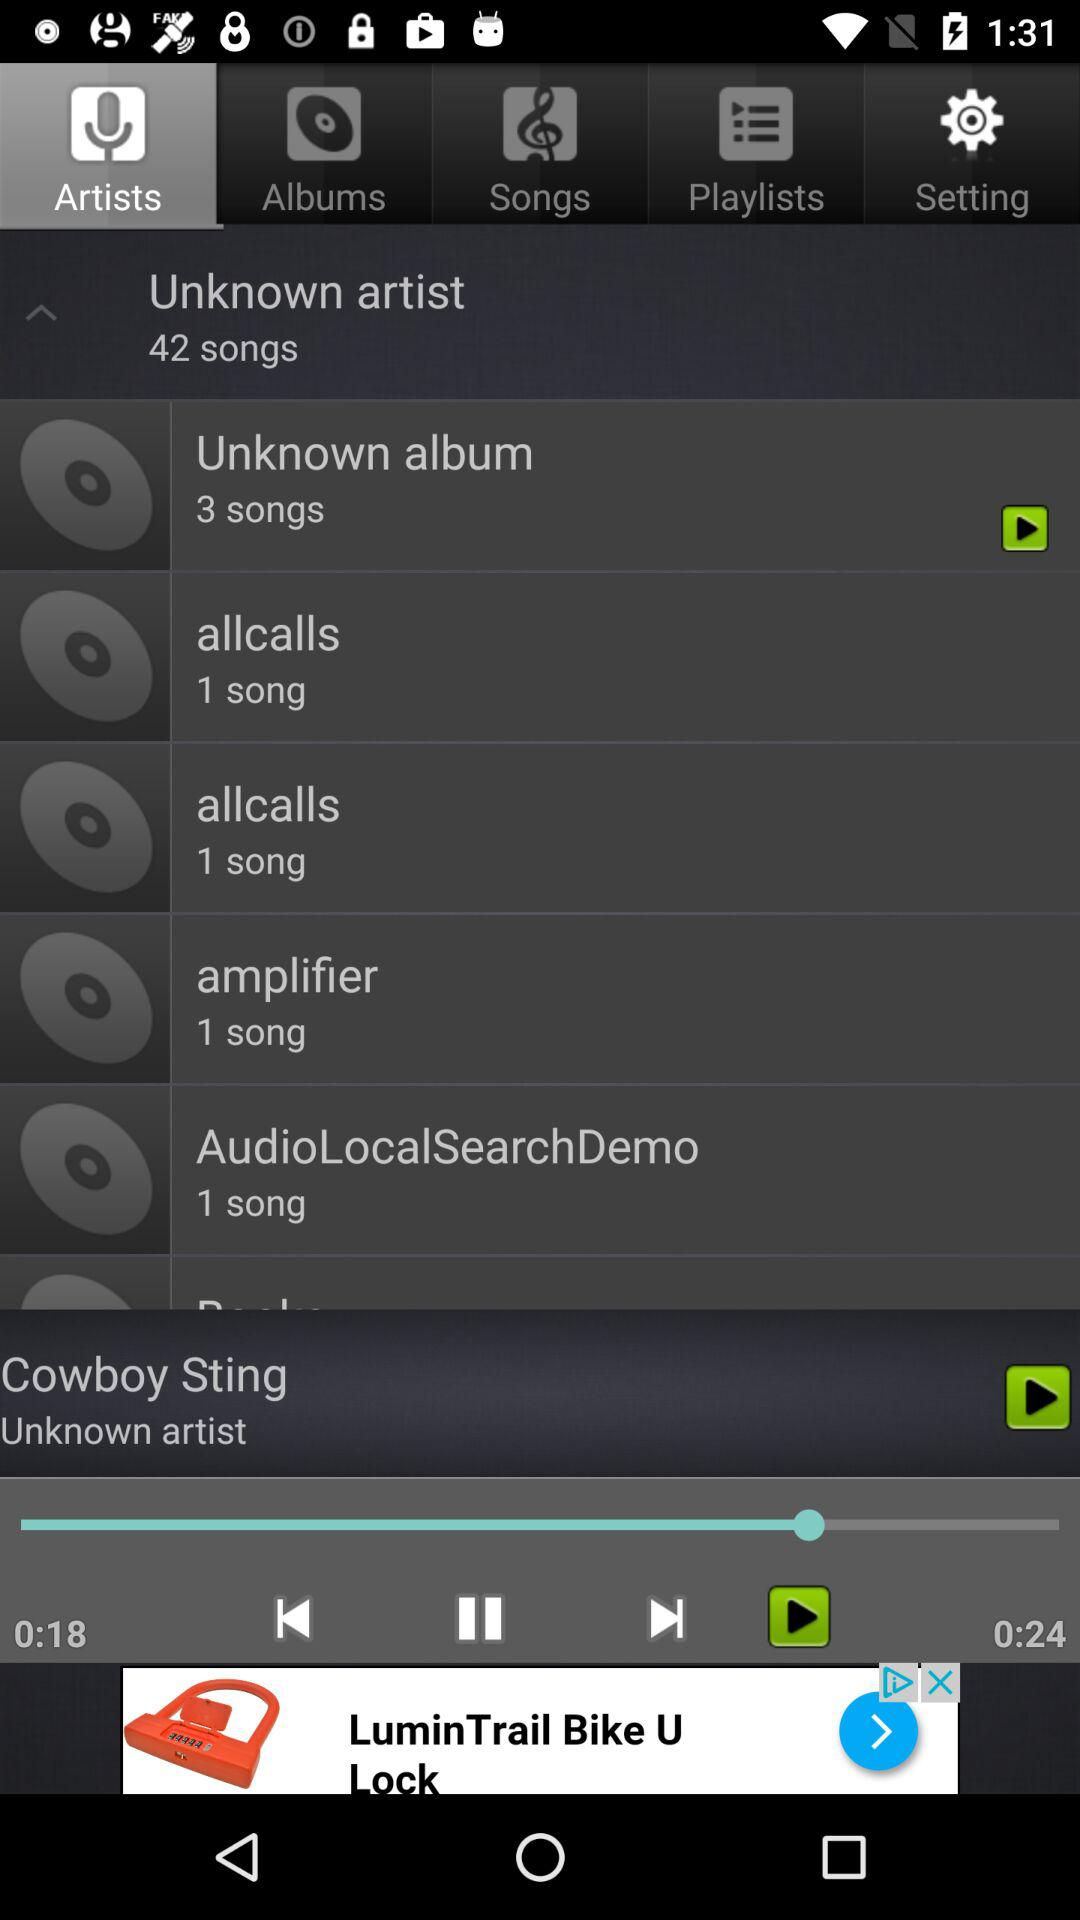What is the duration of the song that is playing? The duration is 24 seconds. 